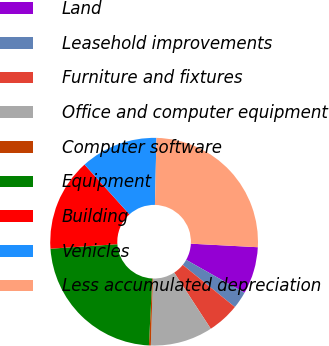Convert chart to OTSL. <chart><loc_0><loc_0><loc_500><loc_500><pie_chart><fcel>Land<fcel>Leasehold improvements<fcel>Furniture and fixtures<fcel>Office and computer equipment<fcel>Computer software<fcel>Equipment<fcel>Building<fcel>Vehicles<fcel>Less accumulated depreciation<nl><fcel>7.34%<fcel>2.64%<fcel>4.99%<fcel>9.69%<fcel>0.29%<fcel>23.13%<fcel>14.39%<fcel>12.04%<fcel>25.48%<nl></chart> 